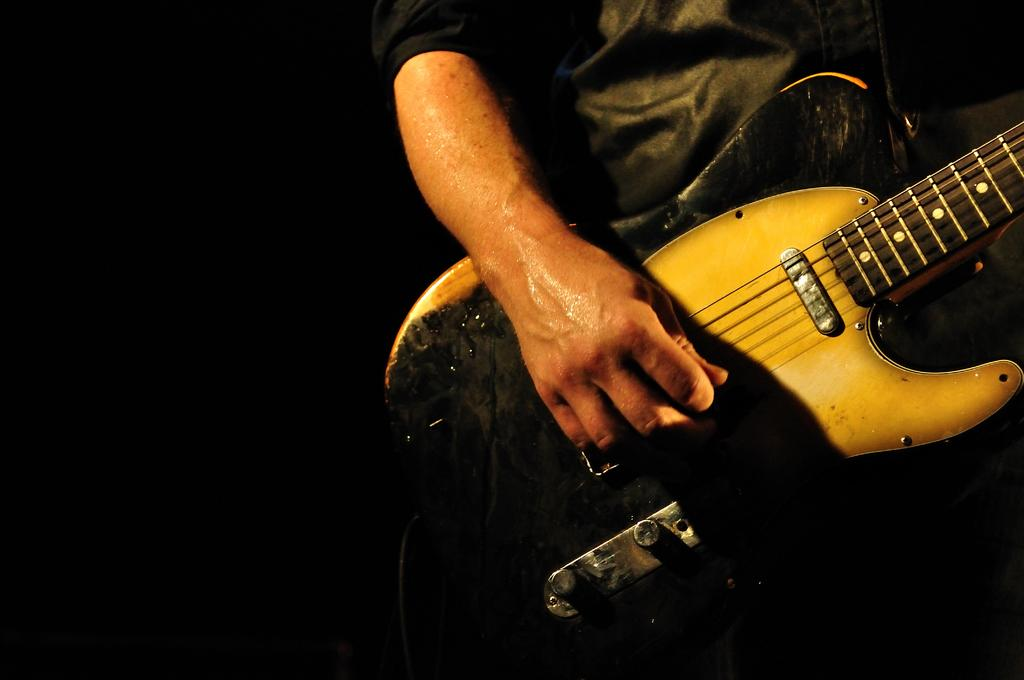What is the main subject of the image? There is a person in the image. What is the person holding in the image? The person is holding a guitar. What type of kite is the person flying in the image? There is no kite present in the image; the person is holding a guitar. What color is the person's polish in the image? There is no mention of polish or any indication that the person's nails are visible in the image. 